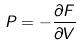<formula> <loc_0><loc_0><loc_500><loc_500>P = - \frac { \partial F } { \partial V }</formula> 